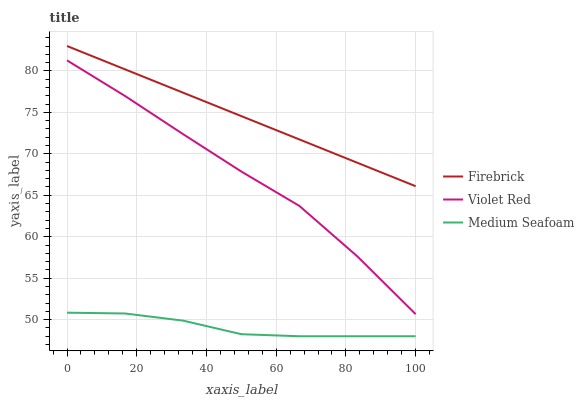Does Medium Seafoam have the minimum area under the curve?
Answer yes or no. Yes. Does Firebrick have the maximum area under the curve?
Answer yes or no. Yes. Does Violet Red have the minimum area under the curve?
Answer yes or no. No. Does Violet Red have the maximum area under the curve?
Answer yes or no. No. Is Firebrick the smoothest?
Answer yes or no. Yes. Is Violet Red the roughest?
Answer yes or no. Yes. Is Medium Seafoam the smoothest?
Answer yes or no. No. Is Medium Seafoam the roughest?
Answer yes or no. No. Does Medium Seafoam have the lowest value?
Answer yes or no. Yes. Does Violet Red have the lowest value?
Answer yes or no. No. Does Firebrick have the highest value?
Answer yes or no. Yes. Does Violet Red have the highest value?
Answer yes or no. No. Is Medium Seafoam less than Violet Red?
Answer yes or no. Yes. Is Firebrick greater than Violet Red?
Answer yes or no. Yes. Does Medium Seafoam intersect Violet Red?
Answer yes or no. No. 